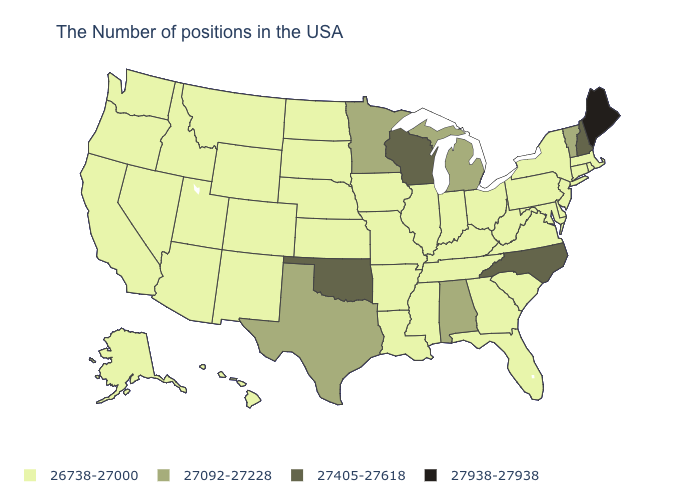Does Missouri have the same value as Minnesota?
Quick response, please. No. What is the value of Maryland?
Answer briefly. 26738-27000. Among the states that border West Virginia , which have the highest value?
Answer briefly. Maryland, Pennsylvania, Virginia, Ohio, Kentucky. Among the states that border Florida , which have the lowest value?
Quick response, please. Georgia. Does Tennessee have the highest value in the USA?
Write a very short answer. No. Does Wisconsin have the highest value in the MidWest?
Answer briefly. Yes. Among the states that border Louisiana , does Texas have the highest value?
Quick response, please. Yes. Name the states that have a value in the range 27092-27228?
Give a very brief answer. Vermont, Michigan, Alabama, Minnesota, Texas. Does Illinois have the same value as Wisconsin?
Quick response, please. No. What is the highest value in the USA?
Concise answer only. 27938-27938. Which states have the lowest value in the USA?
Write a very short answer. Massachusetts, Rhode Island, Connecticut, New York, New Jersey, Delaware, Maryland, Pennsylvania, Virginia, South Carolina, West Virginia, Ohio, Florida, Georgia, Kentucky, Indiana, Tennessee, Illinois, Mississippi, Louisiana, Missouri, Arkansas, Iowa, Kansas, Nebraska, South Dakota, North Dakota, Wyoming, Colorado, New Mexico, Utah, Montana, Arizona, Idaho, Nevada, California, Washington, Oregon, Alaska, Hawaii. Which states hav the highest value in the South?
Answer briefly. North Carolina, Oklahoma. Does the first symbol in the legend represent the smallest category?
Give a very brief answer. Yes. Does the first symbol in the legend represent the smallest category?
Short answer required. Yes. 